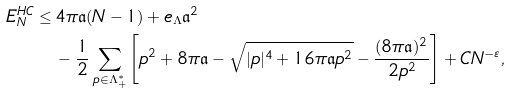Convert formula to latex. <formula><loc_0><loc_0><loc_500><loc_500>E _ { N } ^ { H C } \leq \, & 4 \pi \mathfrak { a } ( N - 1 ) + e _ { \Lambda } \mathfrak { a } ^ { 2 } \\ & - \frac { 1 } { 2 } \sum _ { p \in \Lambda _ { + } ^ { * } } \left [ p ^ { 2 } + 8 \pi \mathfrak { a } - \sqrt { | p | ^ { 4 } + 1 6 \pi \mathfrak { a } p ^ { 2 } } - \frac { ( 8 \pi \mathfrak { a } ) ^ { 2 } } { 2 p ^ { 2 } } \right ] + C N ^ { - \varepsilon } ,</formula> 